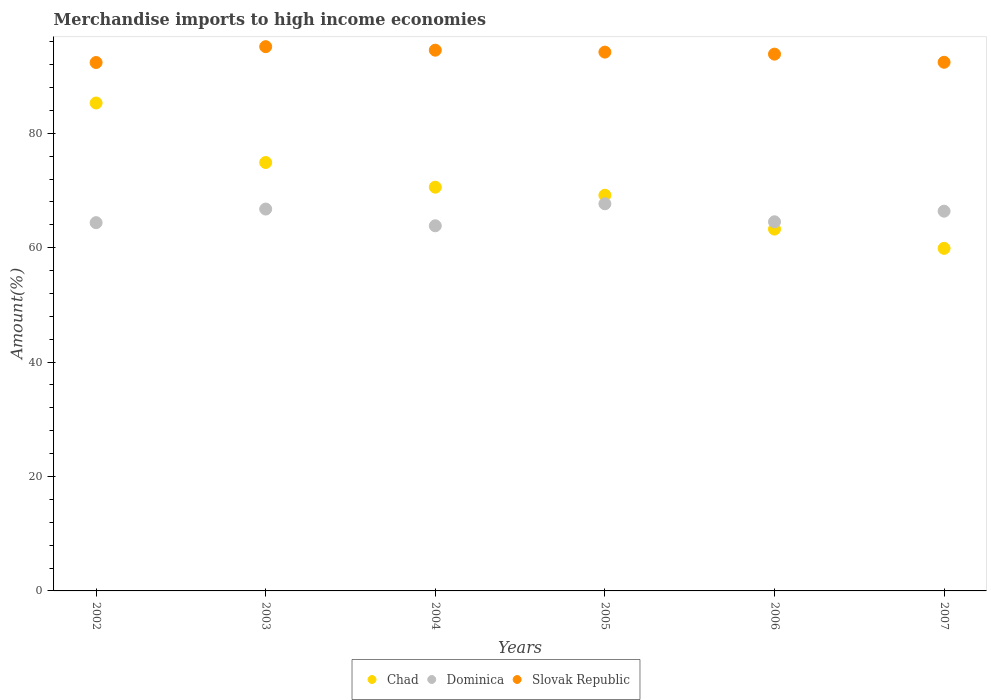Is the number of dotlines equal to the number of legend labels?
Your response must be concise. Yes. What is the percentage of amount earned from merchandise imports in Slovak Republic in 2003?
Your response must be concise. 95.15. Across all years, what is the maximum percentage of amount earned from merchandise imports in Dominica?
Ensure brevity in your answer.  67.68. Across all years, what is the minimum percentage of amount earned from merchandise imports in Dominica?
Make the answer very short. 63.83. In which year was the percentage of amount earned from merchandise imports in Dominica maximum?
Offer a terse response. 2005. In which year was the percentage of amount earned from merchandise imports in Slovak Republic minimum?
Make the answer very short. 2002. What is the total percentage of amount earned from merchandise imports in Slovak Republic in the graph?
Offer a terse response. 562.51. What is the difference between the percentage of amount earned from merchandise imports in Chad in 2003 and that in 2005?
Offer a very short reply. 5.72. What is the difference between the percentage of amount earned from merchandise imports in Chad in 2006 and the percentage of amount earned from merchandise imports in Dominica in 2002?
Your answer should be very brief. -1.12. What is the average percentage of amount earned from merchandise imports in Dominica per year?
Keep it short and to the point. 65.59. In the year 2004, what is the difference between the percentage of amount earned from merchandise imports in Chad and percentage of amount earned from merchandise imports in Slovak Republic?
Offer a terse response. -23.95. What is the ratio of the percentage of amount earned from merchandise imports in Dominica in 2002 to that in 2006?
Offer a terse response. 1. Is the percentage of amount earned from merchandise imports in Dominica in 2002 less than that in 2006?
Give a very brief answer. Yes. What is the difference between the highest and the second highest percentage of amount earned from merchandise imports in Slovak Republic?
Your answer should be compact. 0.62. What is the difference between the highest and the lowest percentage of amount earned from merchandise imports in Dominica?
Give a very brief answer. 3.85. Is the sum of the percentage of amount earned from merchandise imports in Dominica in 2002 and 2007 greater than the maximum percentage of amount earned from merchandise imports in Slovak Republic across all years?
Provide a short and direct response. Yes. Does the percentage of amount earned from merchandise imports in Dominica monotonically increase over the years?
Offer a very short reply. No. How many dotlines are there?
Your answer should be compact. 3. What is the difference between two consecutive major ticks on the Y-axis?
Make the answer very short. 20. Does the graph contain any zero values?
Give a very brief answer. No. Where does the legend appear in the graph?
Provide a short and direct response. Bottom center. How are the legend labels stacked?
Your answer should be very brief. Horizontal. What is the title of the graph?
Your response must be concise. Merchandise imports to high income economies. What is the label or title of the Y-axis?
Ensure brevity in your answer.  Amount(%). What is the Amount(%) in Chad in 2002?
Keep it short and to the point. 85.3. What is the Amount(%) in Dominica in 2002?
Ensure brevity in your answer.  64.38. What is the Amount(%) of Slovak Republic in 2002?
Provide a short and direct response. 92.38. What is the Amount(%) in Chad in 2003?
Give a very brief answer. 74.89. What is the Amount(%) of Dominica in 2003?
Offer a terse response. 66.76. What is the Amount(%) in Slovak Republic in 2003?
Make the answer very short. 95.15. What is the Amount(%) of Chad in 2004?
Offer a very short reply. 70.58. What is the Amount(%) of Dominica in 2004?
Keep it short and to the point. 63.83. What is the Amount(%) of Slovak Republic in 2004?
Offer a very short reply. 94.53. What is the Amount(%) in Chad in 2005?
Give a very brief answer. 69.17. What is the Amount(%) of Dominica in 2005?
Keep it short and to the point. 67.68. What is the Amount(%) in Slovak Republic in 2005?
Give a very brief answer. 94.19. What is the Amount(%) of Chad in 2006?
Your answer should be very brief. 63.26. What is the Amount(%) in Dominica in 2006?
Ensure brevity in your answer.  64.53. What is the Amount(%) in Slovak Republic in 2006?
Offer a very short reply. 93.84. What is the Amount(%) in Chad in 2007?
Give a very brief answer. 59.89. What is the Amount(%) in Dominica in 2007?
Provide a succinct answer. 66.39. What is the Amount(%) of Slovak Republic in 2007?
Ensure brevity in your answer.  92.42. Across all years, what is the maximum Amount(%) of Chad?
Keep it short and to the point. 85.3. Across all years, what is the maximum Amount(%) in Dominica?
Make the answer very short. 67.68. Across all years, what is the maximum Amount(%) in Slovak Republic?
Your answer should be compact. 95.15. Across all years, what is the minimum Amount(%) of Chad?
Provide a succinct answer. 59.89. Across all years, what is the minimum Amount(%) of Dominica?
Ensure brevity in your answer.  63.83. Across all years, what is the minimum Amount(%) of Slovak Republic?
Your answer should be compact. 92.38. What is the total Amount(%) in Chad in the graph?
Keep it short and to the point. 423.09. What is the total Amount(%) in Dominica in the graph?
Your answer should be compact. 393.57. What is the total Amount(%) in Slovak Republic in the graph?
Your response must be concise. 562.51. What is the difference between the Amount(%) in Chad in 2002 and that in 2003?
Your answer should be very brief. 10.4. What is the difference between the Amount(%) of Dominica in 2002 and that in 2003?
Your answer should be very brief. -2.38. What is the difference between the Amount(%) of Slovak Republic in 2002 and that in 2003?
Make the answer very short. -2.77. What is the difference between the Amount(%) in Chad in 2002 and that in 2004?
Your response must be concise. 14.72. What is the difference between the Amount(%) in Dominica in 2002 and that in 2004?
Your response must be concise. 0.55. What is the difference between the Amount(%) of Slovak Republic in 2002 and that in 2004?
Offer a terse response. -2.16. What is the difference between the Amount(%) of Chad in 2002 and that in 2005?
Make the answer very short. 16.12. What is the difference between the Amount(%) of Dominica in 2002 and that in 2005?
Ensure brevity in your answer.  -3.3. What is the difference between the Amount(%) of Slovak Republic in 2002 and that in 2005?
Your answer should be very brief. -1.82. What is the difference between the Amount(%) of Chad in 2002 and that in 2006?
Provide a short and direct response. 22.04. What is the difference between the Amount(%) of Dominica in 2002 and that in 2006?
Give a very brief answer. -0.15. What is the difference between the Amount(%) of Slovak Republic in 2002 and that in 2006?
Provide a short and direct response. -1.46. What is the difference between the Amount(%) of Chad in 2002 and that in 2007?
Offer a very short reply. 25.41. What is the difference between the Amount(%) of Dominica in 2002 and that in 2007?
Give a very brief answer. -2.01. What is the difference between the Amount(%) of Slovak Republic in 2002 and that in 2007?
Give a very brief answer. -0.04. What is the difference between the Amount(%) in Chad in 2003 and that in 2004?
Provide a succinct answer. 4.31. What is the difference between the Amount(%) of Dominica in 2003 and that in 2004?
Give a very brief answer. 2.93. What is the difference between the Amount(%) in Slovak Republic in 2003 and that in 2004?
Your response must be concise. 0.62. What is the difference between the Amount(%) of Chad in 2003 and that in 2005?
Make the answer very short. 5.72. What is the difference between the Amount(%) of Dominica in 2003 and that in 2005?
Keep it short and to the point. -0.92. What is the difference between the Amount(%) in Slovak Republic in 2003 and that in 2005?
Your response must be concise. 0.95. What is the difference between the Amount(%) of Chad in 2003 and that in 2006?
Provide a short and direct response. 11.64. What is the difference between the Amount(%) of Dominica in 2003 and that in 2006?
Offer a very short reply. 2.23. What is the difference between the Amount(%) of Slovak Republic in 2003 and that in 2006?
Give a very brief answer. 1.31. What is the difference between the Amount(%) in Chad in 2003 and that in 2007?
Give a very brief answer. 15.01. What is the difference between the Amount(%) of Dominica in 2003 and that in 2007?
Provide a succinct answer. 0.37. What is the difference between the Amount(%) in Slovak Republic in 2003 and that in 2007?
Give a very brief answer. 2.73. What is the difference between the Amount(%) of Chad in 2004 and that in 2005?
Your response must be concise. 1.41. What is the difference between the Amount(%) in Dominica in 2004 and that in 2005?
Make the answer very short. -3.85. What is the difference between the Amount(%) in Slovak Republic in 2004 and that in 2005?
Your answer should be very brief. 0.34. What is the difference between the Amount(%) in Chad in 2004 and that in 2006?
Make the answer very short. 7.33. What is the difference between the Amount(%) of Dominica in 2004 and that in 2006?
Provide a short and direct response. -0.7. What is the difference between the Amount(%) in Slovak Republic in 2004 and that in 2006?
Provide a succinct answer. 0.69. What is the difference between the Amount(%) of Chad in 2004 and that in 2007?
Keep it short and to the point. 10.69. What is the difference between the Amount(%) in Dominica in 2004 and that in 2007?
Provide a succinct answer. -2.56. What is the difference between the Amount(%) of Slovak Republic in 2004 and that in 2007?
Make the answer very short. 2.11. What is the difference between the Amount(%) of Chad in 2005 and that in 2006?
Your response must be concise. 5.92. What is the difference between the Amount(%) in Dominica in 2005 and that in 2006?
Offer a very short reply. 3.15. What is the difference between the Amount(%) of Slovak Republic in 2005 and that in 2006?
Keep it short and to the point. 0.35. What is the difference between the Amount(%) of Chad in 2005 and that in 2007?
Ensure brevity in your answer.  9.29. What is the difference between the Amount(%) in Dominica in 2005 and that in 2007?
Give a very brief answer. 1.29. What is the difference between the Amount(%) in Slovak Republic in 2005 and that in 2007?
Give a very brief answer. 1.78. What is the difference between the Amount(%) in Chad in 2006 and that in 2007?
Ensure brevity in your answer.  3.37. What is the difference between the Amount(%) in Dominica in 2006 and that in 2007?
Make the answer very short. -1.86. What is the difference between the Amount(%) of Slovak Republic in 2006 and that in 2007?
Provide a succinct answer. 1.42. What is the difference between the Amount(%) of Chad in 2002 and the Amount(%) of Dominica in 2003?
Give a very brief answer. 18.54. What is the difference between the Amount(%) in Chad in 2002 and the Amount(%) in Slovak Republic in 2003?
Offer a very short reply. -9.85. What is the difference between the Amount(%) of Dominica in 2002 and the Amount(%) of Slovak Republic in 2003?
Provide a short and direct response. -30.77. What is the difference between the Amount(%) in Chad in 2002 and the Amount(%) in Dominica in 2004?
Your answer should be compact. 21.47. What is the difference between the Amount(%) in Chad in 2002 and the Amount(%) in Slovak Republic in 2004?
Give a very brief answer. -9.23. What is the difference between the Amount(%) of Dominica in 2002 and the Amount(%) of Slovak Republic in 2004?
Make the answer very short. -30.15. What is the difference between the Amount(%) of Chad in 2002 and the Amount(%) of Dominica in 2005?
Offer a very short reply. 17.62. What is the difference between the Amount(%) in Chad in 2002 and the Amount(%) in Slovak Republic in 2005?
Provide a succinct answer. -8.9. What is the difference between the Amount(%) of Dominica in 2002 and the Amount(%) of Slovak Republic in 2005?
Make the answer very short. -29.82. What is the difference between the Amount(%) in Chad in 2002 and the Amount(%) in Dominica in 2006?
Offer a very short reply. 20.77. What is the difference between the Amount(%) in Chad in 2002 and the Amount(%) in Slovak Republic in 2006?
Offer a terse response. -8.54. What is the difference between the Amount(%) of Dominica in 2002 and the Amount(%) of Slovak Republic in 2006?
Ensure brevity in your answer.  -29.46. What is the difference between the Amount(%) of Chad in 2002 and the Amount(%) of Dominica in 2007?
Provide a short and direct response. 18.91. What is the difference between the Amount(%) in Chad in 2002 and the Amount(%) in Slovak Republic in 2007?
Give a very brief answer. -7.12. What is the difference between the Amount(%) of Dominica in 2002 and the Amount(%) of Slovak Republic in 2007?
Keep it short and to the point. -28.04. What is the difference between the Amount(%) of Chad in 2003 and the Amount(%) of Dominica in 2004?
Provide a short and direct response. 11.06. What is the difference between the Amount(%) in Chad in 2003 and the Amount(%) in Slovak Republic in 2004?
Keep it short and to the point. -19.64. What is the difference between the Amount(%) in Dominica in 2003 and the Amount(%) in Slovak Republic in 2004?
Make the answer very short. -27.77. What is the difference between the Amount(%) in Chad in 2003 and the Amount(%) in Dominica in 2005?
Your answer should be very brief. 7.21. What is the difference between the Amount(%) of Chad in 2003 and the Amount(%) of Slovak Republic in 2005?
Keep it short and to the point. -19.3. What is the difference between the Amount(%) of Dominica in 2003 and the Amount(%) of Slovak Republic in 2005?
Your response must be concise. -27.44. What is the difference between the Amount(%) in Chad in 2003 and the Amount(%) in Dominica in 2006?
Provide a succinct answer. 10.36. What is the difference between the Amount(%) in Chad in 2003 and the Amount(%) in Slovak Republic in 2006?
Provide a short and direct response. -18.95. What is the difference between the Amount(%) of Dominica in 2003 and the Amount(%) of Slovak Republic in 2006?
Your response must be concise. -27.08. What is the difference between the Amount(%) in Chad in 2003 and the Amount(%) in Dominica in 2007?
Keep it short and to the point. 8.51. What is the difference between the Amount(%) in Chad in 2003 and the Amount(%) in Slovak Republic in 2007?
Your response must be concise. -17.52. What is the difference between the Amount(%) in Dominica in 2003 and the Amount(%) in Slovak Republic in 2007?
Provide a succinct answer. -25.66. What is the difference between the Amount(%) in Chad in 2004 and the Amount(%) in Dominica in 2005?
Give a very brief answer. 2.9. What is the difference between the Amount(%) of Chad in 2004 and the Amount(%) of Slovak Republic in 2005?
Offer a very short reply. -23.61. What is the difference between the Amount(%) in Dominica in 2004 and the Amount(%) in Slovak Republic in 2005?
Your response must be concise. -30.36. What is the difference between the Amount(%) of Chad in 2004 and the Amount(%) of Dominica in 2006?
Ensure brevity in your answer.  6.05. What is the difference between the Amount(%) in Chad in 2004 and the Amount(%) in Slovak Republic in 2006?
Give a very brief answer. -23.26. What is the difference between the Amount(%) of Dominica in 2004 and the Amount(%) of Slovak Republic in 2006?
Offer a terse response. -30.01. What is the difference between the Amount(%) of Chad in 2004 and the Amount(%) of Dominica in 2007?
Your response must be concise. 4.19. What is the difference between the Amount(%) in Chad in 2004 and the Amount(%) in Slovak Republic in 2007?
Offer a very short reply. -21.84. What is the difference between the Amount(%) in Dominica in 2004 and the Amount(%) in Slovak Republic in 2007?
Your answer should be very brief. -28.59. What is the difference between the Amount(%) in Chad in 2005 and the Amount(%) in Dominica in 2006?
Your answer should be compact. 4.64. What is the difference between the Amount(%) of Chad in 2005 and the Amount(%) of Slovak Republic in 2006?
Provide a short and direct response. -24.67. What is the difference between the Amount(%) of Dominica in 2005 and the Amount(%) of Slovak Republic in 2006?
Provide a short and direct response. -26.16. What is the difference between the Amount(%) of Chad in 2005 and the Amount(%) of Dominica in 2007?
Offer a very short reply. 2.79. What is the difference between the Amount(%) of Chad in 2005 and the Amount(%) of Slovak Republic in 2007?
Offer a very short reply. -23.24. What is the difference between the Amount(%) in Dominica in 2005 and the Amount(%) in Slovak Republic in 2007?
Provide a succinct answer. -24.74. What is the difference between the Amount(%) in Chad in 2006 and the Amount(%) in Dominica in 2007?
Your response must be concise. -3.13. What is the difference between the Amount(%) of Chad in 2006 and the Amount(%) of Slovak Republic in 2007?
Provide a succinct answer. -29.16. What is the difference between the Amount(%) in Dominica in 2006 and the Amount(%) in Slovak Republic in 2007?
Ensure brevity in your answer.  -27.89. What is the average Amount(%) in Chad per year?
Keep it short and to the point. 70.51. What is the average Amount(%) in Dominica per year?
Provide a succinct answer. 65.59. What is the average Amount(%) of Slovak Republic per year?
Your response must be concise. 93.75. In the year 2002, what is the difference between the Amount(%) in Chad and Amount(%) in Dominica?
Keep it short and to the point. 20.92. In the year 2002, what is the difference between the Amount(%) in Chad and Amount(%) in Slovak Republic?
Your answer should be very brief. -7.08. In the year 2002, what is the difference between the Amount(%) in Dominica and Amount(%) in Slovak Republic?
Make the answer very short. -28. In the year 2003, what is the difference between the Amount(%) of Chad and Amount(%) of Dominica?
Provide a short and direct response. 8.14. In the year 2003, what is the difference between the Amount(%) in Chad and Amount(%) in Slovak Republic?
Your answer should be very brief. -20.25. In the year 2003, what is the difference between the Amount(%) of Dominica and Amount(%) of Slovak Republic?
Your response must be concise. -28.39. In the year 2004, what is the difference between the Amount(%) in Chad and Amount(%) in Dominica?
Offer a very short reply. 6.75. In the year 2004, what is the difference between the Amount(%) in Chad and Amount(%) in Slovak Republic?
Your answer should be very brief. -23.95. In the year 2004, what is the difference between the Amount(%) of Dominica and Amount(%) of Slovak Republic?
Make the answer very short. -30.7. In the year 2005, what is the difference between the Amount(%) of Chad and Amount(%) of Dominica?
Offer a terse response. 1.49. In the year 2005, what is the difference between the Amount(%) in Chad and Amount(%) in Slovak Republic?
Offer a very short reply. -25.02. In the year 2005, what is the difference between the Amount(%) of Dominica and Amount(%) of Slovak Republic?
Your answer should be very brief. -26.51. In the year 2006, what is the difference between the Amount(%) in Chad and Amount(%) in Dominica?
Provide a succinct answer. -1.28. In the year 2006, what is the difference between the Amount(%) in Chad and Amount(%) in Slovak Republic?
Ensure brevity in your answer.  -30.58. In the year 2006, what is the difference between the Amount(%) of Dominica and Amount(%) of Slovak Republic?
Give a very brief answer. -29.31. In the year 2007, what is the difference between the Amount(%) in Chad and Amount(%) in Dominica?
Your response must be concise. -6.5. In the year 2007, what is the difference between the Amount(%) in Chad and Amount(%) in Slovak Republic?
Your answer should be compact. -32.53. In the year 2007, what is the difference between the Amount(%) of Dominica and Amount(%) of Slovak Republic?
Your answer should be very brief. -26.03. What is the ratio of the Amount(%) in Chad in 2002 to that in 2003?
Offer a very short reply. 1.14. What is the ratio of the Amount(%) in Dominica in 2002 to that in 2003?
Make the answer very short. 0.96. What is the ratio of the Amount(%) in Slovak Republic in 2002 to that in 2003?
Make the answer very short. 0.97. What is the ratio of the Amount(%) in Chad in 2002 to that in 2004?
Provide a short and direct response. 1.21. What is the ratio of the Amount(%) in Dominica in 2002 to that in 2004?
Make the answer very short. 1.01. What is the ratio of the Amount(%) in Slovak Republic in 2002 to that in 2004?
Ensure brevity in your answer.  0.98. What is the ratio of the Amount(%) of Chad in 2002 to that in 2005?
Offer a terse response. 1.23. What is the ratio of the Amount(%) of Dominica in 2002 to that in 2005?
Your answer should be very brief. 0.95. What is the ratio of the Amount(%) in Slovak Republic in 2002 to that in 2005?
Ensure brevity in your answer.  0.98. What is the ratio of the Amount(%) of Chad in 2002 to that in 2006?
Offer a terse response. 1.35. What is the ratio of the Amount(%) in Slovak Republic in 2002 to that in 2006?
Provide a succinct answer. 0.98. What is the ratio of the Amount(%) of Chad in 2002 to that in 2007?
Give a very brief answer. 1.42. What is the ratio of the Amount(%) in Dominica in 2002 to that in 2007?
Your response must be concise. 0.97. What is the ratio of the Amount(%) in Chad in 2003 to that in 2004?
Ensure brevity in your answer.  1.06. What is the ratio of the Amount(%) of Dominica in 2003 to that in 2004?
Provide a short and direct response. 1.05. What is the ratio of the Amount(%) of Slovak Republic in 2003 to that in 2004?
Ensure brevity in your answer.  1.01. What is the ratio of the Amount(%) of Chad in 2003 to that in 2005?
Make the answer very short. 1.08. What is the ratio of the Amount(%) in Dominica in 2003 to that in 2005?
Keep it short and to the point. 0.99. What is the ratio of the Amount(%) of Slovak Republic in 2003 to that in 2005?
Your answer should be compact. 1.01. What is the ratio of the Amount(%) in Chad in 2003 to that in 2006?
Your answer should be very brief. 1.18. What is the ratio of the Amount(%) of Dominica in 2003 to that in 2006?
Offer a very short reply. 1.03. What is the ratio of the Amount(%) in Slovak Republic in 2003 to that in 2006?
Keep it short and to the point. 1.01. What is the ratio of the Amount(%) of Chad in 2003 to that in 2007?
Offer a terse response. 1.25. What is the ratio of the Amount(%) in Dominica in 2003 to that in 2007?
Offer a terse response. 1.01. What is the ratio of the Amount(%) of Slovak Republic in 2003 to that in 2007?
Offer a very short reply. 1.03. What is the ratio of the Amount(%) in Chad in 2004 to that in 2005?
Keep it short and to the point. 1.02. What is the ratio of the Amount(%) in Dominica in 2004 to that in 2005?
Give a very brief answer. 0.94. What is the ratio of the Amount(%) in Slovak Republic in 2004 to that in 2005?
Make the answer very short. 1. What is the ratio of the Amount(%) of Chad in 2004 to that in 2006?
Your answer should be compact. 1.12. What is the ratio of the Amount(%) in Dominica in 2004 to that in 2006?
Make the answer very short. 0.99. What is the ratio of the Amount(%) in Slovak Republic in 2004 to that in 2006?
Offer a terse response. 1.01. What is the ratio of the Amount(%) in Chad in 2004 to that in 2007?
Your response must be concise. 1.18. What is the ratio of the Amount(%) in Dominica in 2004 to that in 2007?
Provide a succinct answer. 0.96. What is the ratio of the Amount(%) in Slovak Republic in 2004 to that in 2007?
Offer a terse response. 1.02. What is the ratio of the Amount(%) of Chad in 2005 to that in 2006?
Your response must be concise. 1.09. What is the ratio of the Amount(%) in Dominica in 2005 to that in 2006?
Make the answer very short. 1.05. What is the ratio of the Amount(%) of Slovak Republic in 2005 to that in 2006?
Give a very brief answer. 1. What is the ratio of the Amount(%) of Chad in 2005 to that in 2007?
Keep it short and to the point. 1.16. What is the ratio of the Amount(%) in Dominica in 2005 to that in 2007?
Ensure brevity in your answer.  1.02. What is the ratio of the Amount(%) of Slovak Republic in 2005 to that in 2007?
Your answer should be compact. 1.02. What is the ratio of the Amount(%) in Chad in 2006 to that in 2007?
Make the answer very short. 1.06. What is the ratio of the Amount(%) in Dominica in 2006 to that in 2007?
Your answer should be compact. 0.97. What is the ratio of the Amount(%) in Slovak Republic in 2006 to that in 2007?
Provide a short and direct response. 1.02. What is the difference between the highest and the second highest Amount(%) of Chad?
Provide a succinct answer. 10.4. What is the difference between the highest and the second highest Amount(%) in Dominica?
Make the answer very short. 0.92. What is the difference between the highest and the second highest Amount(%) in Slovak Republic?
Offer a very short reply. 0.62. What is the difference between the highest and the lowest Amount(%) of Chad?
Make the answer very short. 25.41. What is the difference between the highest and the lowest Amount(%) of Dominica?
Offer a terse response. 3.85. What is the difference between the highest and the lowest Amount(%) in Slovak Republic?
Keep it short and to the point. 2.77. 